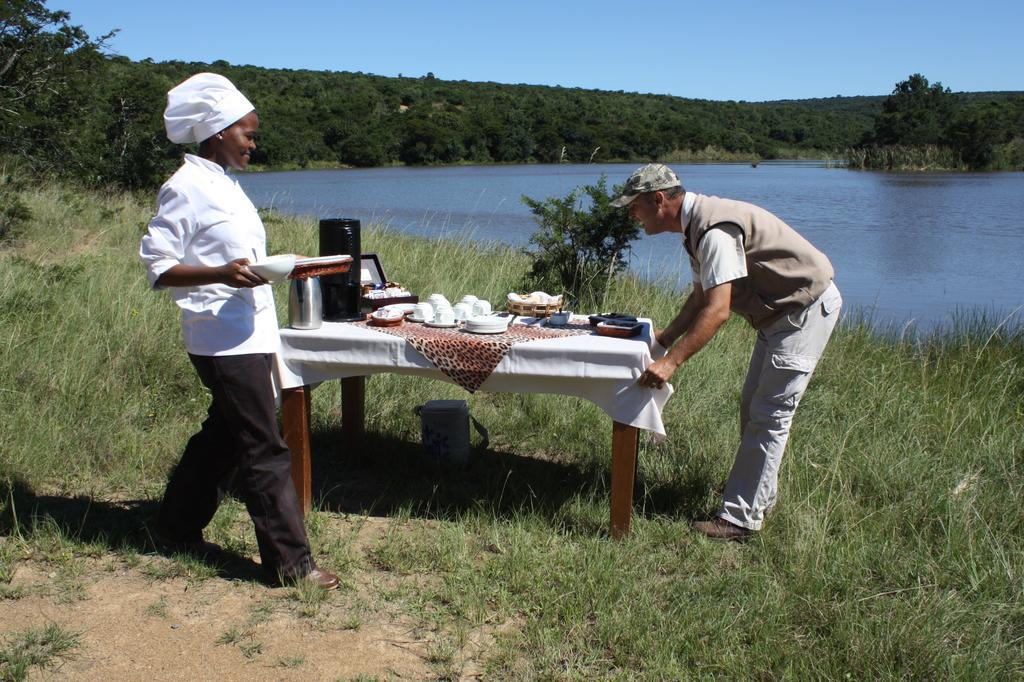Can you describe this image briefly? At the top we can see a clear blue sky. We can see trees. This is a river. We can see a woman chef , holding a plate in her hand and walking near to the table. We can see one man adjusting a cloth. On the table we can see kettle, plate, cups and saucers. This is a grass. Under the table we can see a water can. 